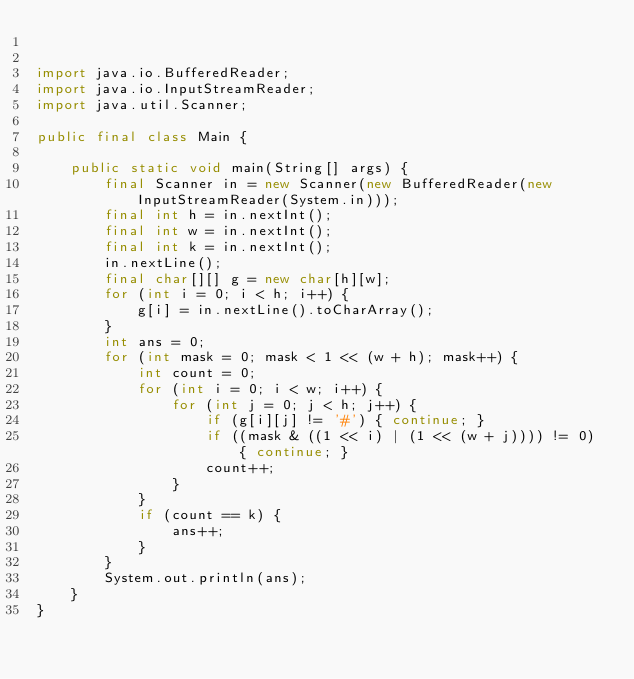Convert code to text. <code><loc_0><loc_0><loc_500><loc_500><_Java_>

import java.io.BufferedReader;
import java.io.InputStreamReader;
import java.util.Scanner;

public final class Main {

    public static void main(String[] args) {
        final Scanner in = new Scanner(new BufferedReader(new InputStreamReader(System.in)));
        final int h = in.nextInt();
        final int w = in.nextInt();
        final int k = in.nextInt();
        in.nextLine();
        final char[][] g = new char[h][w];
        for (int i = 0; i < h; i++) {
            g[i] = in.nextLine().toCharArray();
        }
        int ans = 0;
        for (int mask = 0; mask < 1 << (w + h); mask++) {
            int count = 0;
            for (int i = 0; i < w; i++) {
                for (int j = 0; j < h; j++) {
                    if (g[i][j] != '#') { continue; }
                    if ((mask & ((1 << i) | (1 << (w + j)))) != 0) { continue; }
                    count++;
                }
            }
            if (count == k) {
                ans++;
            }
        }
        System.out.println(ans);
    }
}
</code> 